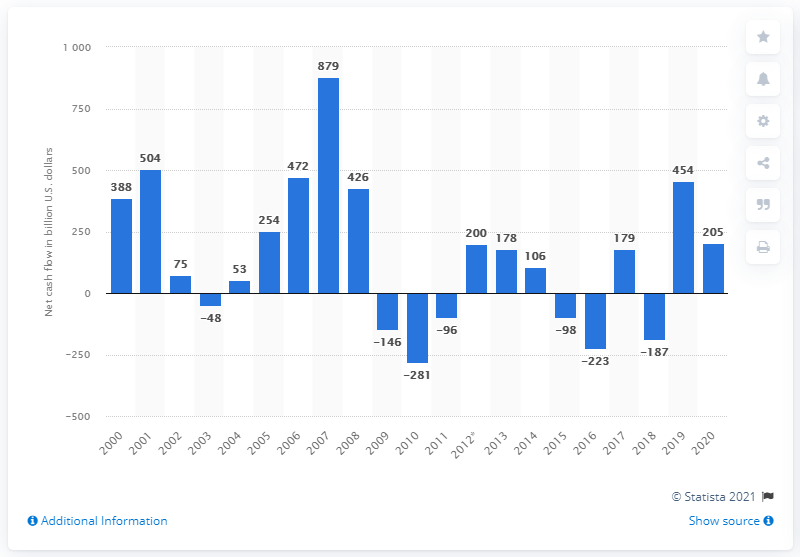Highlight a few significant elements in this photo. The U.S. mutual funds received a significant amount of money in 2020, which is approximately 205 billion dollars. 